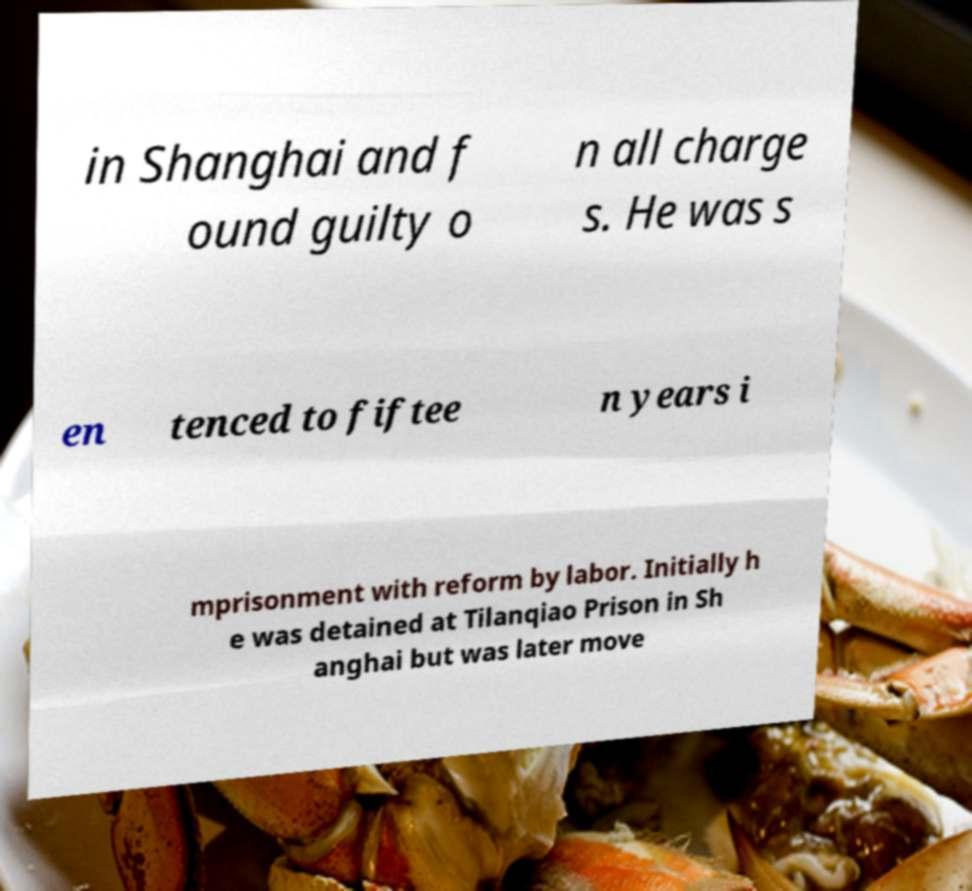Could you extract and type out the text from this image? in Shanghai and f ound guilty o n all charge s. He was s en tenced to fiftee n years i mprisonment with reform by labor. Initially h e was detained at Tilanqiao Prison in Sh anghai but was later move 